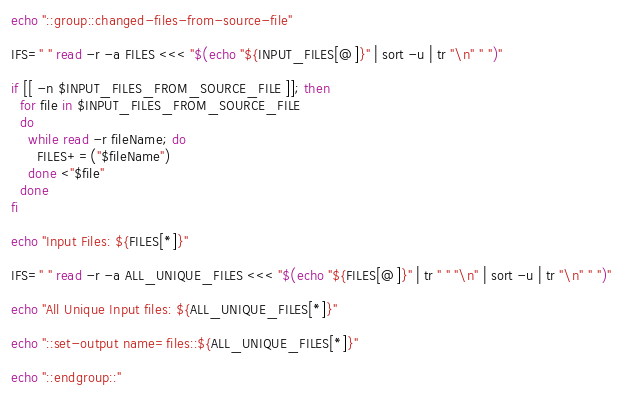Convert code to text. <code><loc_0><loc_0><loc_500><loc_500><_Bash_>echo "::group::changed-files-from-source-file"

IFS=" " read -r -a FILES <<< "$(echo "${INPUT_FILES[@]}" | sort -u | tr "\n" " ")"

if [[ -n $INPUT_FILES_FROM_SOURCE_FILE ]]; then
  for file in $INPUT_FILES_FROM_SOURCE_FILE
  do
    while read -r fileName; do
      FILES+=("$fileName")
    done <"$file"
  done
fi

echo "Input Files: ${FILES[*]}"

IFS=" " read -r -a ALL_UNIQUE_FILES <<< "$(echo "${FILES[@]}" | tr " " "\n" | sort -u | tr "\n" " ")"

echo "All Unique Input files: ${ALL_UNIQUE_FILES[*]}"

echo "::set-output name=files::${ALL_UNIQUE_FILES[*]}"

echo "::endgroup::"
</code> 